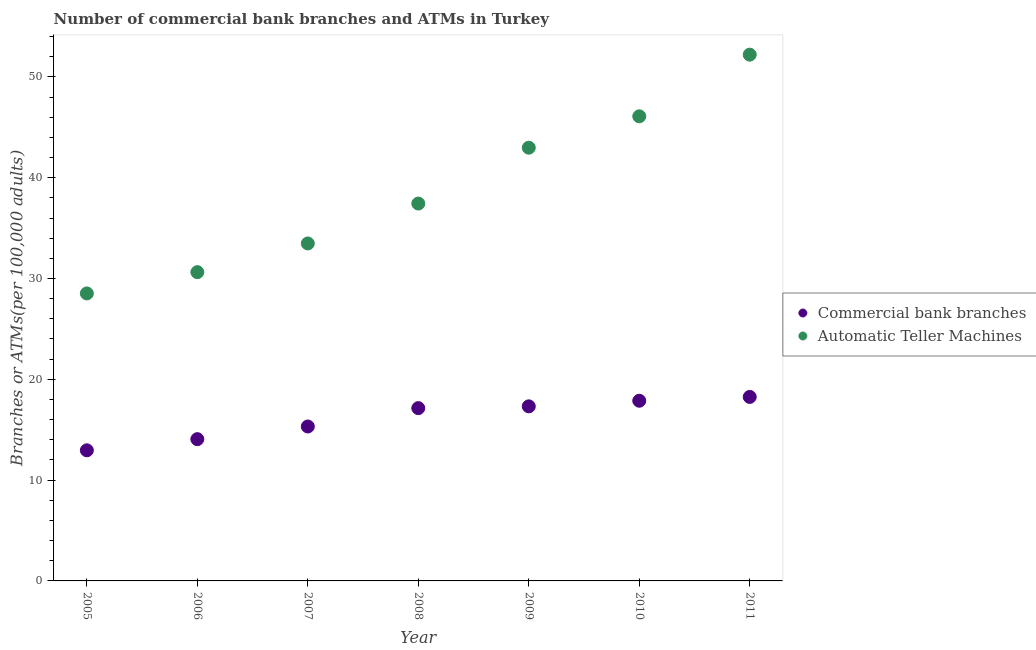How many different coloured dotlines are there?
Your response must be concise. 2. Is the number of dotlines equal to the number of legend labels?
Offer a terse response. Yes. What is the number of atms in 2009?
Keep it short and to the point. 42.98. Across all years, what is the maximum number of atms?
Keep it short and to the point. 52.21. Across all years, what is the minimum number of atms?
Provide a succinct answer. 28.52. In which year was the number of atms maximum?
Provide a short and direct response. 2011. What is the total number of atms in the graph?
Provide a succinct answer. 271.33. What is the difference between the number of atms in 2005 and that in 2010?
Provide a short and direct response. -17.57. What is the difference between the number of atms in 2005 and the number of commercal bank branches in 2008?
Offer a terse response. 11.38. What is the average number of commercal bank branches per year?
Give a very brief answer. 16.13. In the year 2010, what is the difference between the number of atms and number of commercal bank branches?
Offer a terse response. 28.22. In how many years, is the number of atms greater than 34?
Offer a terse response. 4. What is the ratio of the number of commercal bank branches in 2007 to that in 2011?
Make the answer very short. 0.84. What is the difference between the highest and the second highest number of commercal bank branches?
Keep it short and to the point. 0.38. What is the difference between the highest and the lowest number of commercal bank branches?
Give a very brief answer. 5.3. Is the sum of the number of atms in 2009 and 2011 greater than the maximum number of commercal bank branches across all years?
Offer a very short reply. Yes. Does the number of commercal bank branches monotonically increase over the years?
Make the answer very short. Yes. Is the number of atms strictly greater than the number of commercal bank branches over the years?
Provide a succinct answer. Yes. How many dotlines are there?
Make the answer very short. 2. Does the graph contain any zero values?
Provide a succinct answer. No. Does the graph contain grids?
Offer a very short reply. No. What is the title of the graph?
Offer a terse response. Number of commercial bank branches and ATMs in Turkey. Does "Quality of trade" appear as one of the legend labels in the graph?
Offer a terse response. No. What is the label or title of the Y-axis?
Your answer should be compact. Branches or ATMs(per 100,0 adults). What is the Branches or ATMs(per 100,000 adults) of Commercial bank branches in 2005?
Your response must be concise. 12.96. What is the Branches or ATMs(per 100,000 adults) in Automatic Teller Machines in 2005?
Offer a terse response. 28.52. What is the Branches or ATMs(per 100,000 adults) in Commercial bank branches in 2006?
Offer a terse response. 14.06. What is the Branches or ATMs(per 100,000 adults) in Automatic Teller Machines in 2006?
Make the answer very short. 30.63. What is the Branches or ATMs(per 100,000 adults) of Commercial bank branches in 2007?
Keep it short and to the point. 15.32. What is the Branches or ATMs(per 100,000 adults) in Automatic Teller Machines in 2007?
Provide a succinct answer. 33.48. What is the Branches or ATMs(per 100,000 adults) in Commercial bank branches in 2008?
Offer a terse response. 17.14. What is the Branches or ATMs(per 100,000 adults) in Automatic Teller Machines in 2008?
Your answer should be compact. 37.44. What is the Branches or ATMs(per 100,000 adults) in Commercial bank branches in 2009?
Give a very brief answer. 17.32. What is the Branches or ATMs(per 100,000 adults) in Automatic Teller Machines in 2009?
Your response must be concise. 42.98. What is the Branches or ATMs(per 100,000 adults) in Commercial bank branches in 2010?
Offer a very short reply. 17.87. What is the Branches or ATMs(per 100,000 adults) of Automatic Teller Machines in 2010?
Provide a succinct answer. 46.09. What is the Branches or ATMs(per 100,000 adults) of Commercial bank branches in 2011?
Provide a short and direct response. 18.25. What is the Branches or ATMs(per 100,000 adults) of Automatic Teller Machines in 2011?
Offer a very short reply. 52.21. Across all years, what is the maximum Branches or ATMs(per 100,000 adults) of Commercial bank branches?
Keep it short and to the point. 18.25. Across all years, what is the maximum Branches or ATMs(per 100,000 adults) of Automatic Teller Machines?
Give a very brief answer. 52.21. Across all years, what is the minimum Branches or ATMs(per 100,000 adults) of Commercial bank branches?
Offer a terse response. 12.96. Across all years, what is the minimum Branches or ATMs(per 100,000 adults) of Automatic Teller Machines?
Provide a short and direct response. 28.52. What is the total Branches or ATMs(per 100,000 adults) of Commercial bank branches in the graph?
Keep it short and to the point. 112.92. What is the total Branches or ATMs(per 100,000 adults) in Automatic Teller Machines in the graph?
Give a very brief answer. 271.33. What is the difference between the Branches or ATMs(per 100,000 adults) in Commercial bank branches in 2005 and that in 2006?
Give a very brief answer. -1.11. What is the difference between the Branches or ATMs(per 100,000 adults) in Automatic Teller Machines in 2005 and that in 2006?
Your response must be concise. -2.11. What is the difference between the Branches or ATMs(per 100,000 adults) of Commercial bank branches in 2005 and that in 2007?
Offer a terse response. -2.36. What is the difference between the Branches or ATMs(per 100,000 adults) in Automatic Teller Machines in 2005 and that in 2007?
Your answer should be very brief. -4.96. What is the difference between the Branches or ATMs(per 100,000 adults) of Commercial bank branches in 2005 and that in 2008?
Provide a succinct answer. -4.19. What is the difference between the Branches or ATMs(per 100,000 adults) of Automatic Teller Machines in 2005 and that in 2008?
Offer a terse response. -8.92. What is the difference between the Branches or ATMs(per 100,000 adults) of Commercial bank branches in 2005 and that in 2009?
Your response must be concise. -4.36. What is the difference between the Branches or ATMs(per 100,000 adults) in Automatic Teller Machines in 2005 and that in 2009?
Provide a succinct answer. -14.46. What is the difference between the Branches or ATMs(per 100,000 adults) of Commercial bank branches in 2005 and that in 2010?
Keep it short and to the point. -4.92. What is the difference between the Branches or ATMs(per 100,000 adults) in Automatic Teller Machines in 2005 and that in 2010?
Give a very brief answer. -17.57. What is the difference between the Branches or ATMs(per 100,000 adults) of Commercial bank branches in 2005 and that in 2011?
Provide a succinct answer. -5.3. What is the difference between the Branches or ATMs(per 100,000 adults) of Automatic Teller Machines in 2005 and that in 2011?
Offer a terse response. -23.69. What is the difference between the Branches or ATMs(per 100,000 adults) of Commercial bank branches in 2006 and that in 2007?
Offer a very short reply. -1.26. What is the difference between the Branches or ATMs(per 100,000 adults) of Automatic Teller Machines in 2006 and that in 2007?
Offer a very short reply. -2.85. What is the difference between the Branches or ATMs(per 100,000 adults) in Commercial bank branches in 2006 and that in 2008?
Keep it short and to the point. -3.08. What is the difference between the Branches or ATMs(per 100,000 adults) of Automatic Teller Machines in 2006 and that in 2008?
Make the answer very short. -6.81. What is the difference between the Branches or ATMs(per 100,000 adults) in Commercial bank branches in 2006 and that in 2009?
Make the answer very short. -3.25. What is the difference between the Branches or ATMs(per 100,000 adults) of Automatic Teller Machines in 2006 and that in 2009?
Offer a very short reply. -12.35. What is the difference between the Branches or ATMs(per 100,000 adults) of Commercial bank branches in 2006 and that in 2010?
Your answer should be compact. -3.81. What is the difference between the Branches or ATMs(per 100,000 adults) of Automatic Teller Machines in 2006 and that in 2010?
Your response must be concise. -15.46. What is the difference between the Branches or ATMs(per 100,000 adults) in Commercial bank branches in 2006 and that in 2011?
Your answer should be very brief. -4.19. What is the difference between the Branches or ATMs(per 100,000 adults) in Automatic Teller Machines in 2006 and that in 2011?
Keep it short and to the point. -21.58. What is the difference between the Branches or ATMs(per 100,000 adults) of Commercial bank branches in 2007 and that in 2008?
Offer a terse response. -1.82. What is the difference between the Branches or ATMs(per 100,000 adults) in Automatic Teller Machines in 2007 and that in 2008?
Offer a terse response. -3.96. What is the difference between the Branches or ATMs(per 100,000 adults) of Commercial bank branches in 2007 and that in 2009?
Keep it short and to the point. -2. What is the difference between the Branches or ATMs(per 100,000 adults) of Automatic Teller Machines in 2007 and that in 2009?
Provide a short and direct response. -9.5. What is the difference between the Branches or ATMs(per 100,000 adults) of Commercial bank branches in 2007 and that in 2010?
Offer a terse response. -2.56. What is the difference between the Branches or ATMs(per 100,000 adults) in Automatic Teller Machines in 2007 and that in 2010?
Offer a terse response. -12.61. What is the difference between the Branches or ATMs(per 100,000 adults) in Commercial bank branches in 2007 and that in 2011?
Keep it short and to the point. -2.94. What is the difference between the Branches or ATMs(per 100,000 adults) of Automatic Teller Machines in 2007 and that in 2011?
Keep it short and to the point. -18.73. What is the difference between the Branches or ATMs(per 100,000 adults) of Commercial bank branches in 2008 and that in 2009?
Provide a short and direct response. -0.18. What is the difference between the Branches or ATMs(per 100,000 adults) in Automatic Teller Machines in 2008 and that in 2009?
Give a very brief answer. -5.54. What is the difference between the Branches or ATMs(per 100,000 adults) in Commercial bank branches in 2008 and that in 2010?
Provide a short and direct response. -0.73. What is the difference between the Branches or ATMs(per 100,000 adults) in Automatic Teller Machines in 2008 and that in 2010?
Make the answer very short. -8.65. What is the difference between the Branches or ATMs(per 100,000 adults) of Commercial bank branches in 2008 and that in 2011?
Provide a short and direct response. -1.11. What is the difference between the Branches or ATMs(per 100,000 adults) of Automatic Teller Machines in 2008 and that in 2011?
Provide a succinct answer. -14.77. What is the difference between the Branches or ATMs(per 100,000 adults) in Commercial bank branches in 2009 and that in 2010?
Offer a terse response. -0.56. What is the difference between the Branches or ATMs(per 100,000 adults) of Automatic Teller Machines in 2009 and that in 2010?
Provide a succinct answer. -3.11. What is the difference between the Branches or ATMs(per 100,000 adults) of Commercial bank branches in 2009 and that in 2011?
Offer a very short reply. -0.94. What is the difference between the Branches or ATMs(per 100,000 adults) in Automatic Teller Machines in 2009 and that in 2011?
Make the answer very short. -9.23. What is the difference between the Branches or ATMs(per 100,000 adults) in Commercial bank branches in 2010 and that in 2011?
Offer a very short reply. -0.38. What is the difference between the Branches or ATMs(per 100,000 adults) of Automatic Teller Machines in 2010 and that in 2011?
Provide a short and direct response. -6.12. What is the difference between the Branches or ATMs(per 100,000 adults) of Commercial bank branches in 2005 and the Branches or ATMs(per 100,000 adults) of Automatic Teller Machines in 2006?
Offer a terse response. -17.67. What is the difference between the Branches or ATMs(per 100,000 adults) in Commercial bank branches in 2005 and the Branches or ATMs(per 100,000 adults) in Automatic Teller Machines in 2007?
Provide a short and direct response. -20.52. What is the difference between the Branches or ATMs(per 100,000 adults) of Commercial bank branches in 2005 and the Branches or ATMs(per 100,000 adults) of Automatic Teller Machines in 2008?
Your answer should be very brief. -24.48. What is the difference between the Branches or ATMs(per 100,000 adults) in Commercial bank branches in 2005 and the Branches or ATMs(per 100,000 adults) in Automatic Teller Machines in 2009?
Ensure brevity in your answer.  -30.02. What is the difference between the Branches or ATMs(per 100,000 adults) in Commercial bank branches in 2005 and the Branches or ATMs(per 100,000 adults) in Automatic Teller Machines in 2010?
Provide a succinct answer. -33.13. What is the difference between the Branches or ATMs(per 100,000 adults) of Commercial bank branches in 2005 and the Branches or ATMs(per 100,000 adults) of Automatic Teller Machines in 2011?
Your answer should be compact. -39.25. What is the difference between the Branches or ATMs(per 100,000 adults) in Commercial bank branches in 2006 and the Branches or ATMs(per 100,000 adults) in Automatic Teller Machines in 2007?
Make the answer very short. -19.41. What is the difference between the Branches or ATMs(per 100,000 adults) of Commercial bank branches in 2006 and the Branches or ATMs(per 100,000 adults) of Automatic Teller Machines in 2008?
Provide a short and direct response. -23.37. What is the difference between the Branches or ATMs(per 100,000 adults) in Commercial bank branches in 2006 and the Branches or ATMs(per 100,000 adults) in Automatic Teller Machines in 2009?
Your answer should be compact. -28.91. What is the difference between the Branches or ATMs(per 100,000 adults) in Commercial bank branches in 2006 and the Branches or ATMs(per 100,000 adults) in Automatic Teller Machines in 2010?
Your answer should be very brief. -32.03. What is the difference between the Branches or ATMs(per 100,000 adults) in Commercial bank branches in 2006 and the Branches or ATMs(per 100,000 adults) in Automatic Teller Machines in 2011?
Your answer should be very brief. -38.14. What is the difference between the Branches or ATMs(per 100,000 adults) in Commercial bank branches in 2007 and the Branches or ATMs(per 100,000 adults) in Automatic Teller Machines in 2008?
Offer a terse response. -22.12. What is the difference between the Branches or ATMs(per 100,000 adults) in Commercial bank branches in 2007 and the Branches or ATMs(per 100,000 adults) in Automatic Teller Machines in 2009?
Your answer should be compact. -27.66. What is the difference between the Branches or ATMs(per 100,000 adults) of Commercial bank branches in 2007 and the Branches or ATMs(per 100,000 adults) of Automatic Teller Machines in 2010?
Offer a terse response. -30.77. What is the difference between the Branches or ATMs(per 100,000 adults) in Commercial bank branches in 2007 and the Branches or ATMs(per 100,000 adults) in Automatic Teller Machines in 2011?
Keep it short and to the point. -36.89. What is the difference between the Branches or ATMs(per 100,000 adults) of Commercial bank branches in 2008 and the Branches or ATMs(per 100,000 adults) of Automatic Teller Machines in 2009?
Make the answer very short. -25.84. What is the difference between the Branches or ATMs(per 100,000 adults) in Commercial bank branches in 2008 and the Branches or ATMs(per 100,000 adults) in Automatic Teller Machines in 2010?
Offer a terse response. -28.95. What is the difference between the Branches or ATMs(per 100,000 adults) in Commercial bank branches in 2008 and the Branches or ATMs(per 100,000 adults) in Automatic Teller Machines in 2011?
Ensure brevity in your answer.  -35.06. What is the difference between the Branches or ATMs(per 100,000 adults) of Commercial bank branches in 2009 and the Branches or ATMs(per 100,000 adults) of Automatic Teller Machines in 2010?
Offer a terse response. -28.77. What is the difference between the Branches or ATMs(per 100,000 adults) in Commercial bank branches in 2009 and the Branches or ATMs(per 100,000 adults) in Automatic Teller Machines in 2011?
Ensure brevity in your answer.  -34.89. What is the difference between the Branches or ATMs(per 100,000 adults) of Commercial bank branches in 2010 and the Branches or ATMs(per 100,000 adults) of Automatic Teller Machines in 2011?
Your answer should be compact. -34.33. What is the average Branches or ATMs(per 100,000 adults) in Commercial bank branches per year?
Give a very brief answer. 16.13. What is the average Branches or ATMs(per 100,000 adults) of Automatic Teller Machines per year?
Offer a very short reply. 38.76. In the year 2005, what is the difference between the Branches or ATMs(per 100,000 adults) in Commercial bank branches and Branches or ATMs(per 100,000 adults) in Automatic Teller Machines?
Ensure brevity in your answer.  -15.56. In the year 2006, what is the difference between the Branches or ATMs(per 100,000 adults) in Commercial bank branches and Branches or ATMs(per 100,000 adults) in Automatic Teller Machines?
Offer a terse response. -16.57. In the year 2007, what is the difference between the Branches or ATMs(per 100,000 adults) of Commercial bank branches and Branches or ATMs(per 100,000 adults) of Automatic Teller Machines?
Provide a short and direct response. -18.16. In the year 2008, what is the difference between the Branches or ATMs(per 100,000 adults) of Commercial bank branches and Branches or ATMs(per 100,000 adults) of Automatic Teller Machines?
Make the answer very short. -20.29. In the year 2009, what is the difference between the Branches or ATMs(per 100,000 adults) of Commercial bank branches and Branches or ATMs(per 100,000 adults) of Automatic Teller Machines?
Provide a succinct answer. -25.66. In the year 2010, what is the difference between the Branches or ATMs(per 100,000 adults) of Commercial bank branches and Branches or ATMs(per 100,000 adults) of Automatic Teller Machines?
Offer a very short reply. -28.22. In the year 2011, what is the difference between the Branches or ATMs(per 100,000 adults) in Commercial bank branches and Branches or ATMs(per 100,000 adults) in Automatic Teller Machines?
Keep it short and to the point. -33.95. What is the ratio of the Branches or ATMs(per 100,000 adults) in Commercial bank branches in 2005 to that in 2006?
Keep it short and to the point. 0.92. What is the ratio of the Branches or ATMs(per 100,000 adults) of Automatic Teller Machines in 2005 to that in 2006?
Your answer should be compact. 0.93. What is the ratio of the Branches or ATMs(per 100,000 adults) of Commercial bank branches in 2005 to that in 2007?
Give a very brief answer. 0.85. What is the ratio of the Branches or ATMs(per 100,000 adults) in Automatic Teller Machines in 2005 to that in 2007?
Ensure brevity in your answer.  0.85. What is the ratio of the Branches or ATMs(per 100,000 adults) of Commercial bank branches in 2005 to that in 2008?
Make the answer very short. 0.76. What is the ratio of the Branches or ATMs(per 100,000 adults) of Automatic Teller Machines in 2005 to that in 2008?
Your answer should be very brief. 0.76. What is the ratio of the Branches or ATMs(per 100,000 adults) in Commercial bank branches in 2005 to that in 2009?
Make the answer very short. 0.75. What is the ratio of the Branches or ATMs(per 100,000 adults) in Automatic Teller Machines in 2005 to that in 2009?
Provide a short and direct response. 0.66. What is the ratio of the Branches or ATMs(per 100,000 adults) of Commercial bank branches in 2005 to that in 2010?
Your answer should be very brief. 0.72. What is the ratio of the Branches or ATMs(per 100,000 adults) in Automatic Teller Machines in 2005 to that in 2010?
Your answer should be very brief. 0.62. What is the ratio of the Branches or ATMs(per 100,000 adults) in Commercial bank branches in 2005 to that in 2011?
Keep it short and to the point. 0.71. What is the ratio of the Branches or ATMs(per 100,000 adults) in Automatic Teller Machines in 2005 to that in 2011?
Offer a very short reply. 0.55. What is the ratio of the Branches or ATMs(per 100,000 adults) in Commercial bank branches in 2006 to that in 2007?
Your answer should be very brief. 0.92. What is the ratio of the Branches or ATMs(per 100,000 adults) in Automatic Teller Machines in 2006 to that in 2007?
Your answer should be very brief. 0.92. What is the ratio of the Branches or ATMs(per 100,000 adults) in Commercial bank branches in 2006 to that in 2008?
Provide a succinct answer. 0.82. What is the ratio of the Branches or ATMs(per 100,000 adults) in Automatic Teller Machines in 2006 to that in 2008?
Your answer should be compact. 0.82. What is the ratio of the Branches or ATMs(per 100,000 adults) in Commercial bank branches in 2006 to that in 2009?
Make the answer very short. 0.81. What is the ratio of the Branches or ATMs(per 100,000 adults) in Automatic Teller Machines in 2006 to that in 2009?
Keep it short and to the point. 0.71. What is the ratio of the Branches or ATMs(per 100,000 adults) in Commercial bank branches in 2006 to that in 2010?
Offer a very short reply. 0.79. What is the ratio of the Branches or ATMs(per 100,000 adults) of Automatic Teller Machines in 2006 to that in 2010?
Offer a terse response. 0.66. What is the ratio of the Branches or ATMs(per 100,000 adults) of Commercial bank branches in 2006 to that in 2011?
Make the answer very short. 0.77. What is the ratio of the Branches or ATMs(per 100,000 adults) in Automatic Teller Machines in 2006 to that in 2011?
Your answer should be compact. 0.59. What is the ratio of the Branches or ATMs(per 100,000 adults) of Commercial bank branches in 2007 to that in 2008?
Provide a succinct answer. 0.89. What is the ratio of the Branches or ATMs(per 100,000 adults) of Automatic Teller Machines in 2007 to that in 2008?
Your response must be concise. 0.89. What is the ratio of the Branches or ATMs(per 100,000 adults) of Commercial bank branches in 2007 to that in 2009?
Your response must be concise. 0.88. What is the ratio of the Branches or ATMs(per 100,000 adults) of Automatic Teller Machines in 2007 to that in 2009?
Provide a succinct answer. 0.78. What is the ratio of the Branches or ATMs(per 100,000 adults) of Commercial bank branches in 2007 to that in 2010?
Offer a terse response. 0.86. What is the ratio of the Branches or ATMs(per 100,000 adults) in Automatic Teller Machines in 2007 to that in 2010?
Your answer should be very brief. 0.73. What is the ratio of the Branches or ATMs(per 100,000 adults) in Commercial bank branches in 2007 to that in 2011?
Offer a very short reply. 0.84. What is the ratio of the Branches or ATMs(per 100,000 adults) of Automatic Teller Machines in 2007 to that in 2011?
Provide a succinct answer. 0.64. What is the ratio of the Branches or ATMs(per 100,000 adults) of Commercial bank branches in 2008 to that in 2009?
Keep it short and to the point. 0.99. What is the ratio of the Branches or ATMs(per 100,000 adults) in Automatic Teller Machines in 2008 to that in 2009?
Ensure brevity in your answer.  0.87. What is the ratio of the Branches or ATMs(per 100,000 adults) of Automatic Teller Machines in 2008 to that in 2010?
Keep it short and to the point. 0.81. What is the ratio of the Branches or ATMs(per 100,000 adults) of Commercial bank branches in 2008 to that in 2011?
Offer a very short reply. 0.94. What is the ratio of the Branches or ATMs(per 100,000 adults) of Automatic Teller Machines in 2008 to that in 2011?
Make the answer very short. 0.72. What is the ratio of the Branches or ATMs(per 100,000 adults) in Commercial bank branches in 2009 to that in 2010?
Offer a terse response. 0.97. What is the ratio of the Branches or ATMs(per 100,000 adults) of Automatic Teller Machines in 2009 to that in 2010?
Make the answer very short. 0.93. What is the ratio of the Branches or ATMs(per 100,000 adults) of Commercial bank branches in 2009 to that in 2011?
Give a very brief answer. 0.95. What is the ratio of the Branches or ATMs(per 100,000 adults) of Automatic Teller Machines in 2009 to that in 2011?
Give a very brief answer. 0.82. What is the ratio of the Branches or ATMs(per 100,000 adults) of Commercial bank branches in 2010 to that in 2011?
Your answer should be compact. 0.98. What is the ratio of the Branches or ATMs(per 100,000 adults) of Automatic Teller Machines in 2010 to that in 2011?
Provide a short and direct response. 0.88. What is the difference between the highest and the second highest Branches or ATMs(per 100,000 adults) of Commercial bank branches?
Ensure brevity in your answer.  0.38. What is the difference between the highest and the second highest Branches or ATMs(per 100,000 adults) in Automatic Teller Machines?
Give a very brief answer. 6.12. What is the difference between the highest and the lowest Branches or ATMs(per 100,000 adults) of Commercial bank branches?
Provide a succinct answer. 5.3. What is the difference between the highest and the lowest Branches or ATMs(per 100,000 adults) in Automatic Teller Machines?
Offer a terse response. 23.69. 